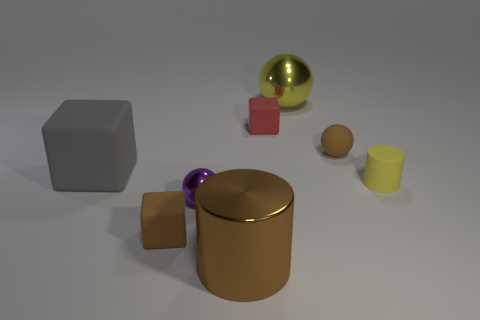There is a rubber cube that is on the right side of the small block that is in front of the brown matte thing to the right of the red matte block; what size is it? The rubber cube referred to appears to be relatively small, especially when compared to the other objects in the scene. It seems to be designed to represent a smaller scale object, much like a toy cube, which would typically measure a few centimeters in each dimension. 